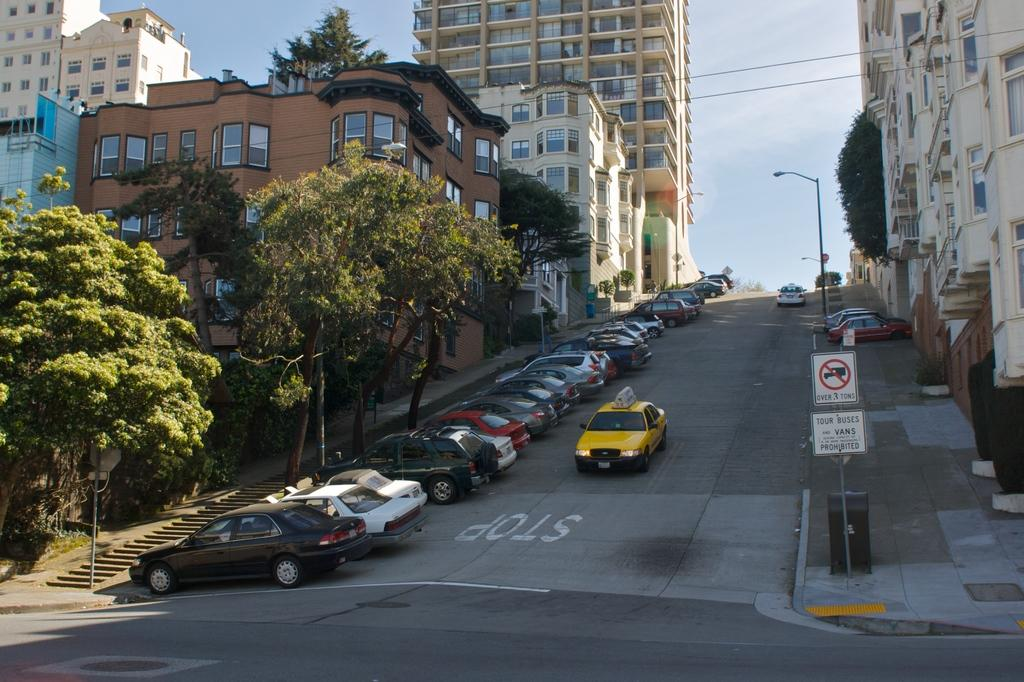<image>
Describe the image concisely. A Taxi going down a big hill in a dense suburban street that says Stop 